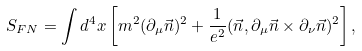<formula> <loc_0><loc_0><loc_500><loc_500>S _ { F N } = \int d ^ { 4 } x \left [ m ^ { 2 } ( \partial _ { \mu } \vec { n } ) ^ { 2 } + \frac { 1 } { e ^ { 2 } } ( \vec { n } , \partial _ { \mu } \vec { n } \times \partial _ { \nu } \vec { n } ) ^ { 2 } \right ] ,</formula> 